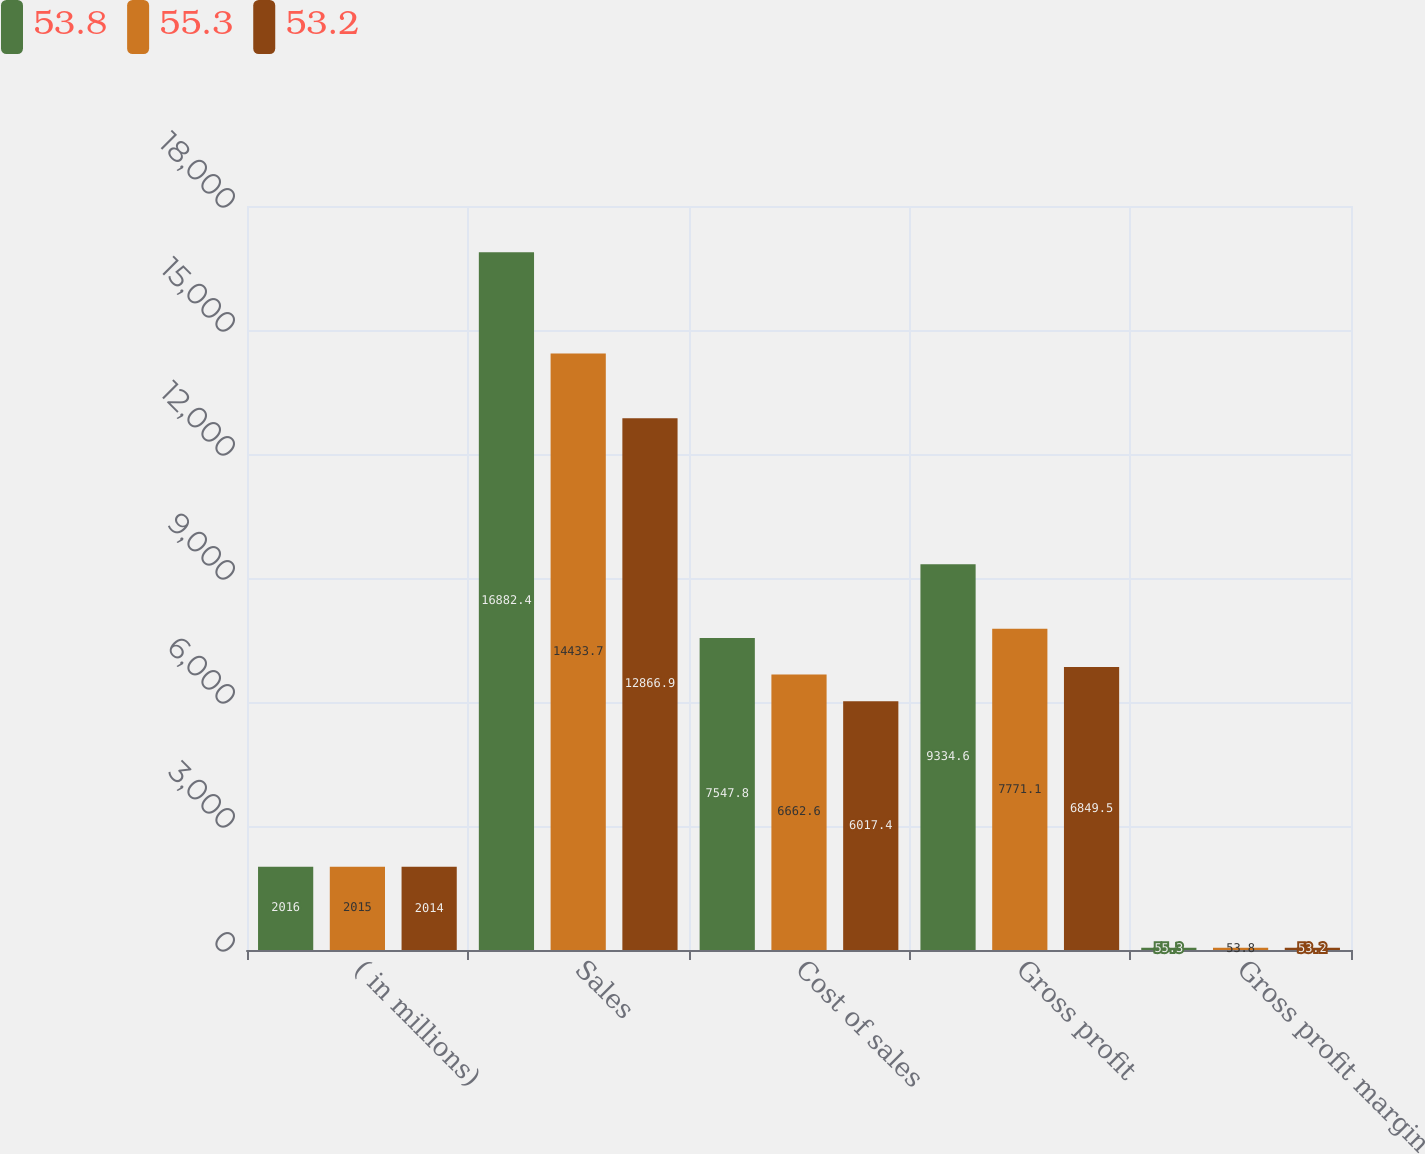Convert chart to OTSL. <chart><loc_0><loc_0><loc_500><loc_500><stacked_bar_chart><ecel><fcel>( in millions)<fcel>Sales<fcel>Cost of sales<fcel>Gross profit<fcel>Gross profit margin<nl><fcel>53.8<fcel>2016<fcel>16882.4<fcel>7547.8<fcel>9334.6<fcel>55.3<nl><fcel>55.3<fcel>2015<fcel>14433.7<fcel>6662.6<fcel>7771.1<fcel>53.8<nl><fcel>53.2<fcel>2014<fcel>12866.9<fcel>6017.4<fcel>6849.5<fcel>53.2<nl></chart> 